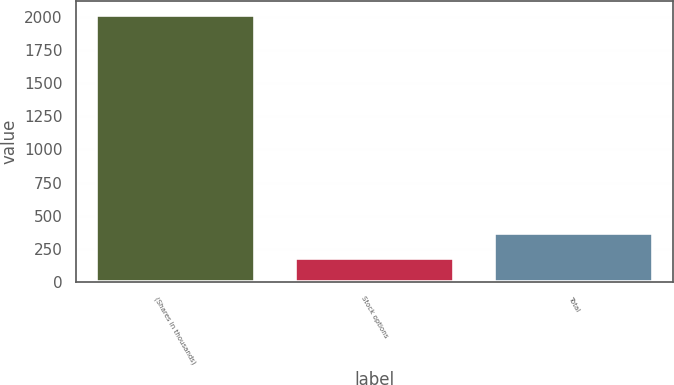Convert chart to OTSL. <chart><loc_0><loc_0><loc_500><loc_500><bar_chart><fcel>(Shares in thousands)<fcel>Stock options<fcel>Total<nl><fcel>2015<fcel>185<fcel>368<nl></chart> 